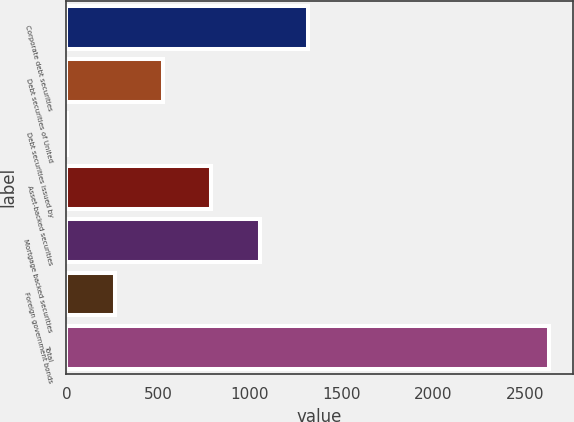Convert chart. <chart><loc_0><loc_0><loc_500><loc_500><bar_chart><fcel>Corporate debt securities<fcel>Debt securities of United<fcel>Debt securities issued by<fcel>Asset-backed securities<fcel>Mortgage backed securities<fcel>Foreign government bonds<fcel>Total<nl><fcel>1315.5<fcel>528<fcel>3<fcel>790.5<fcel>1053<fcel>265.5<fcel>2628<nl></chart> 